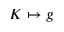Convert formula to latex. <formula><loc_0><loc_0><loc_500><loc_500>K \mapsto g</formula> 